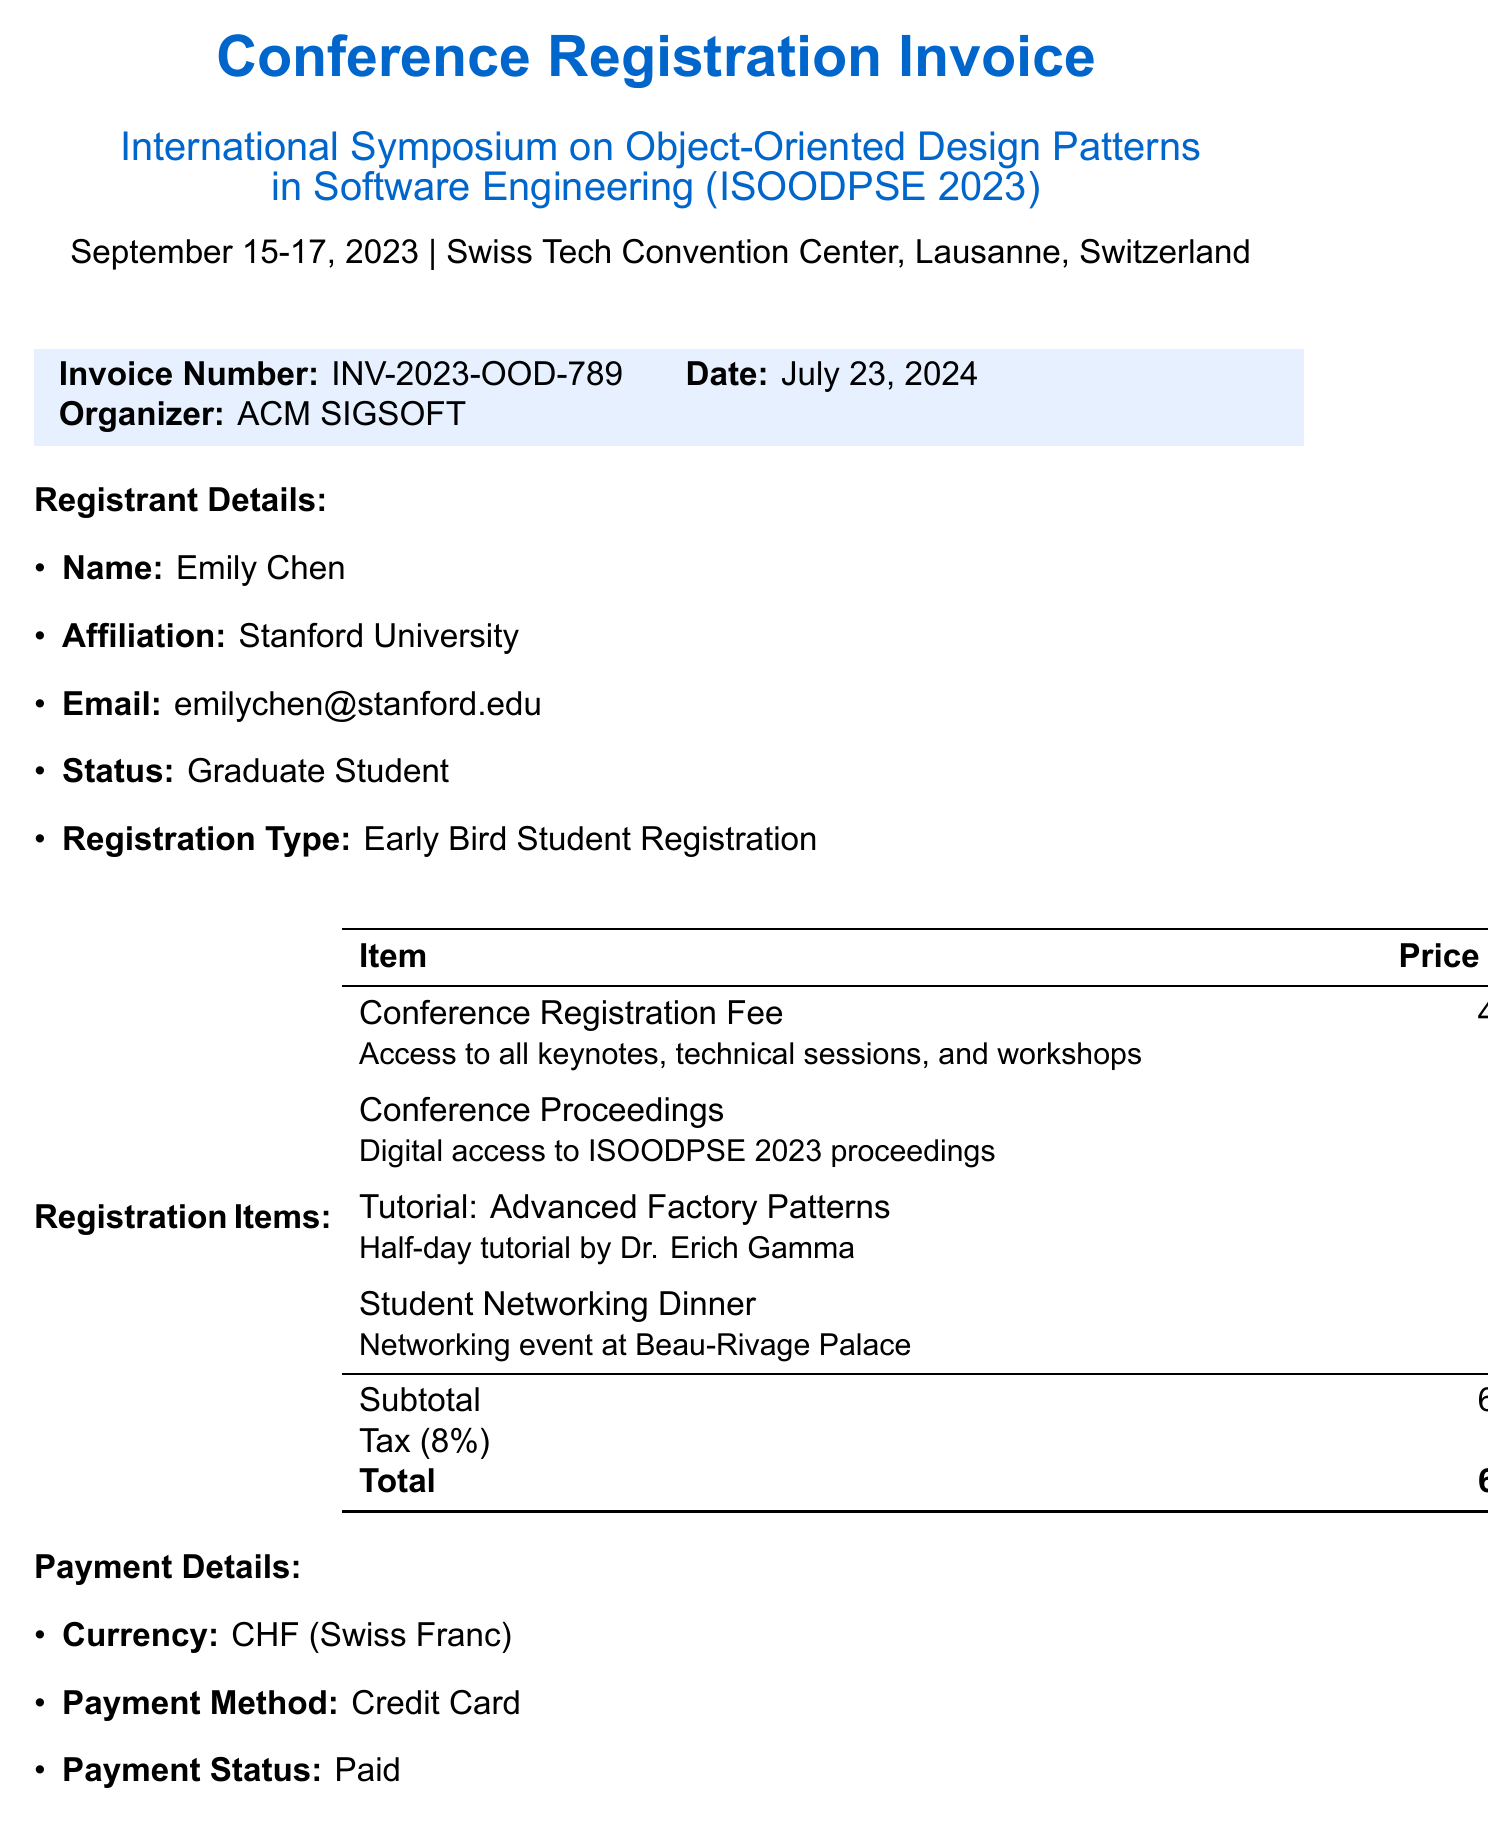What is the invoice number? The invoice number is a unique identifier for the invoice, listed clearly in the document.
Answer: INV-2023-OOD-789 Who is the registrant? The registrant's name, affiliation, email, and status are detailed in the document.
Answer: Emily Chen What is the total amount due? The total amount due is the final amount calculated including all fees and taxes.
Answer: 653.40 What is the venue of the conference? The venue indicates where the conference takes place, specified in the document.
Answer: Swiss Tech Convention Center, Lausanne, Switzerland Who is the contact person for the event? The contact person is someone the registrant can reach out to for inquiries regarding the conference.
Answer: Dr. Sarah Mueller What is the registration type? The registration type describes the category of registration selected by the registrant.
Answer: Early Bird Student Registration What is the cancellation policy? The cancellation policy outlines the refund terms associated with canceling the registration.
Answer: 50% refund for cancellations before August 15, 2023. No refunds after this date What is the description of the tutorial included? The description provides additional detail about the content and facilitator of the tutorial.
Answer: Half-day tutorial by Dr. Erich Gamma How much was the tax charged? The tax amount is a specific figure representing taxes applied to the subtotal.
Answer: 48.40 